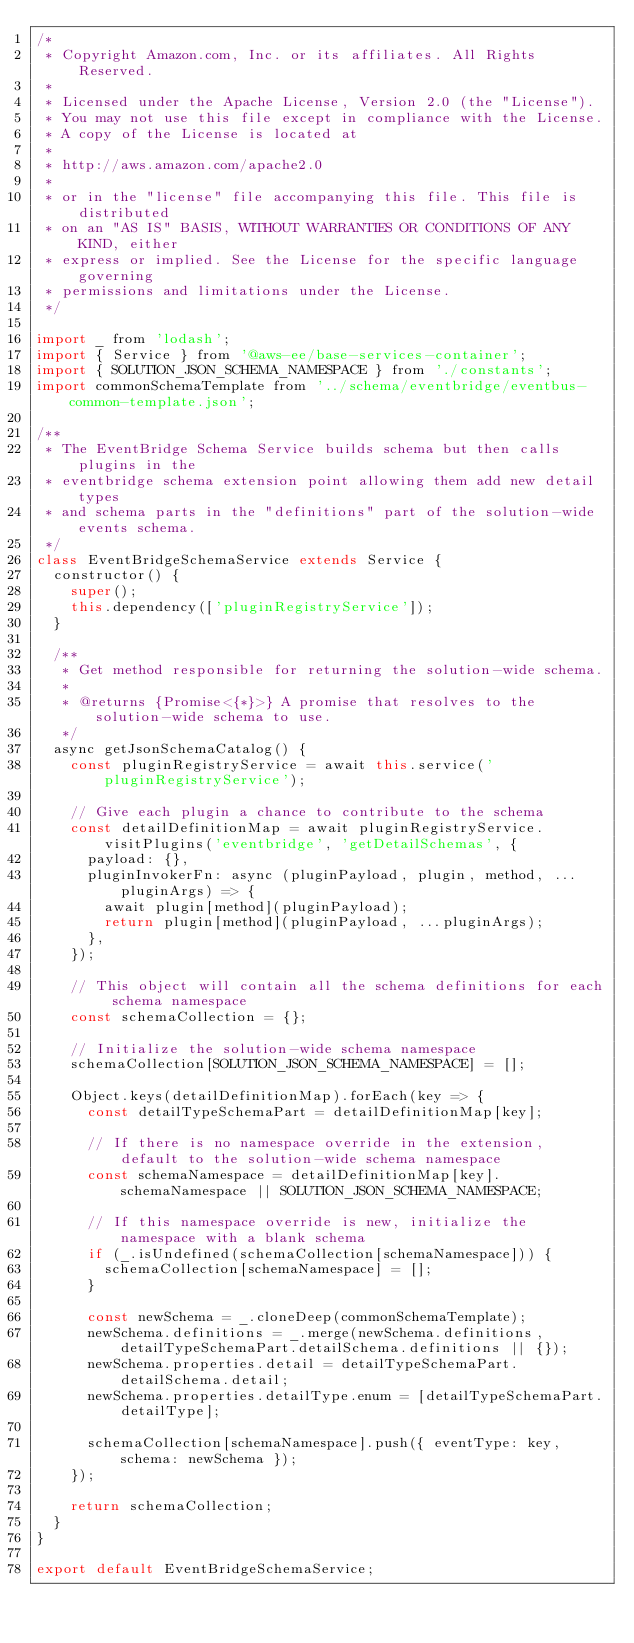<code> <loc_0><loc_0><loc_500><loc_500><_JavaScript_>/*
 * Copyright Amazon.com, Inc. or its affiliates. All Rights Reserved.
 *
 * Licensed under the Apache License, Version 2.0 (the "License").
 * You may not use this file except in compliance with the License.
 * A copy of the License is located at
 *
 * http://aws.amazon.com/apache2.0
 *
 * or in the "license" file accompanying this file. This file is distributed
 * on an "AS IS" BASIS, WITHOUT WARRANTIES OR CONDITIONS OF ANY KIND, either
 * express or implied. See the License for the specific language governing
 * permissions and limitations under the License.
 */

import _ from 'lodash';
import { Service } from '@aws-ee/base-services-container';
import { SOLUTION_JSON_SCHEMA_NAMESPACE } from './constants';
import commonSchemaTemplate from '../schema/eventbridge/eventbus-common-template.json';

/**
 * The EventBridge Schema Service builds schema but then calls plugins in the
 * eventbridge schema extension point allowing them add new detail types
 * and schema parts in the "definitions" part of the solution-wide events schema.
 */
class EventBridgeSchemaService extends Service {
  constructor() {
    super();
    this.dependency(['pluginRegistryService']);
  }

  /**
   * Get method responsible for returning the solution-wide schema.
   *
   * @returns {Promise<{*}>} A promise that resolves to the solution-wide schema to use.
   */
  async getJsonSchemaCatalog() {
    const pluginRegistryService = await this.service('pluginRegistryService');

    // Give each plugin a chance to contribute to the schema
    const detailDefinitionMap = await pluginRegistryService.visitPlugins('eventbridge', 'getDetailSchemas', {
      payload: {},
      pluginInvokerFn: async (pluginPayload, plugin, method, ...pluginArgs) => {
        await plugin[method](pluginPayload);
        return plugin[method](pluginPayload, ...pluginArgs);
      },
    });

    // This object will contain all the schema definitions for each schema namespace
    const schemaCollection = {};

    // Initialize the solution-wide schema namespace
    schemaCollection[SOLUTION_JSON_SCHEMA_NAMESPACE] = [];

    Object.keys(detailDefinitionMap).forEach(key => {
      const detailTypeSchemaPart = detailDefinitionMap[key];

      // If there is no namespace override in the extension, default to the solution-wide schema namespace
      const schemaNamespace = detailDefinitionMap[key].schemaNamespace || SOLUTION_JSON_SCHEMA_NAMESPACE;

      // If this namespace override is new, initialize the namespace with a blank schema
      if (_.isUndefined(schemaCollection[schemaNamespace])) {
        schemaCollection[schemaNamespace] = [];
      }

      const newSchema = _.cloneDeep(commonSchemaTemplate);
      newSchema.definitions = _.merge(newSchema.definitions, detailTypeSchemaPart.detailSchema.definitions || {});
      newSchema.properties.detail = detailTypeSchemaPart.detailSchema.detail;
      newSchema.properties.detailType.enum = [detailTypeSchemaPart.detailType];

      schemaCollection[schemaNamespace].push({ eventType: key, schema: newSchema });
    });

    return schemaCollection;
  }
}

export default EventBridgeSchemaService;
</code> 